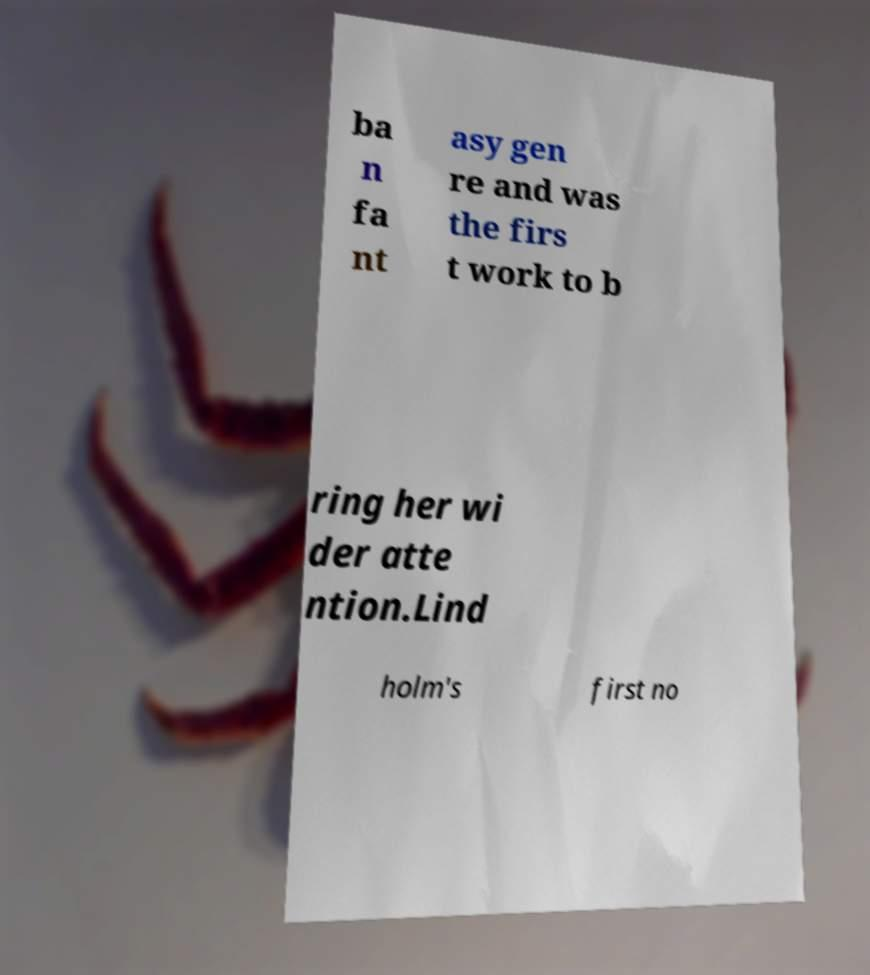Please read and relay the text visible in this image. What does it say? ba n fa nt asy gen re and was the firs t work to b ring her wi der atte ntion.Lind holm's first no 